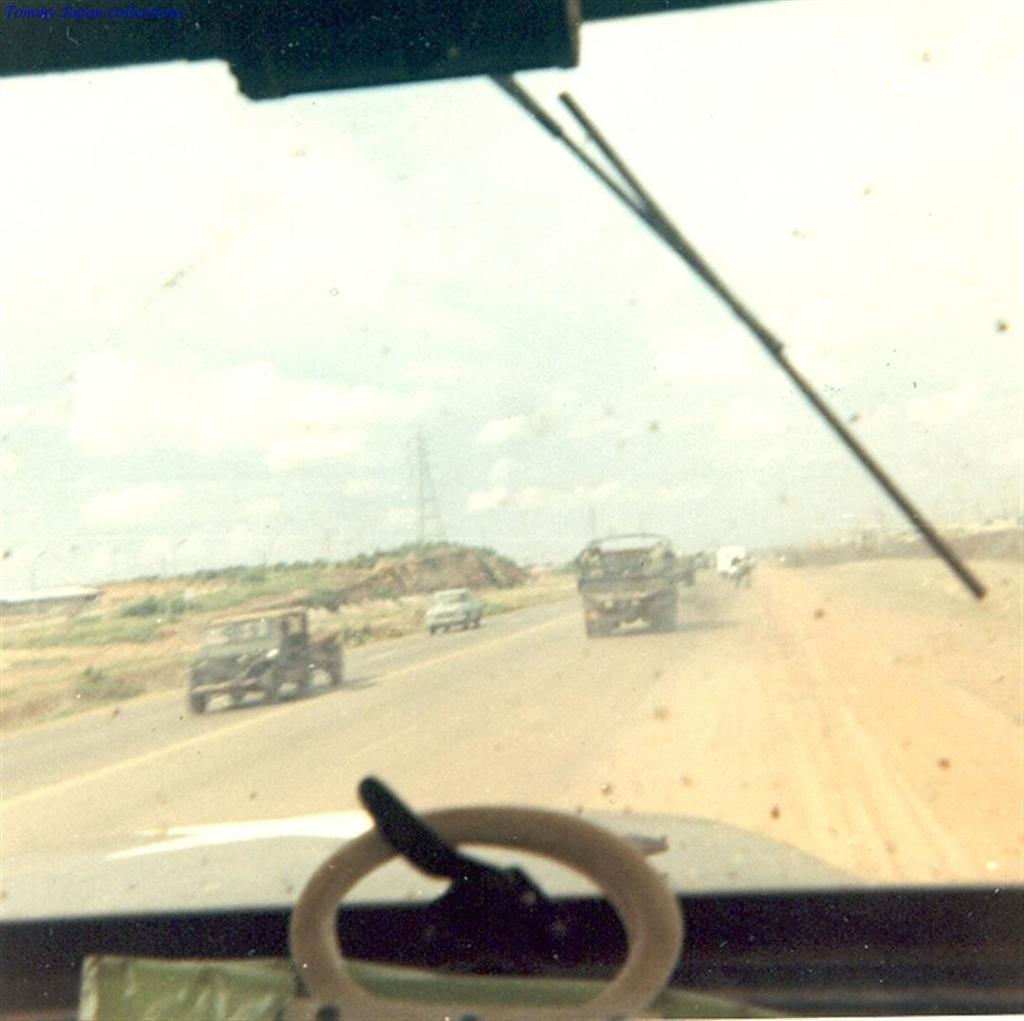Can you describe this image briefly? In this picture, from the vehicle's windshield, I can see few vehicles moving on the road and I can see a tower and I can see sky. 